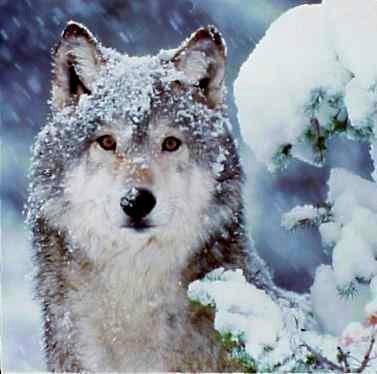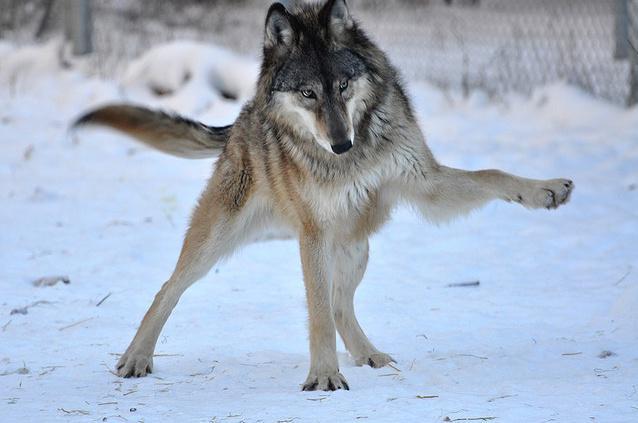The first image is the image on the left, the second image is the image on the right. Given the left and right images, does the statement "An image shows exactly two different colored wolves interacting playfully in the snow, one with its rear toward the camera." hold true? Answer yes or no. No. The first image is the image on the left, the second image is the image on the right. Evaluate the accuracy of this statement regarding the images: "Two dogs are standing in the snow in the image on the right.". Is it true? Answer yes or no. No. 